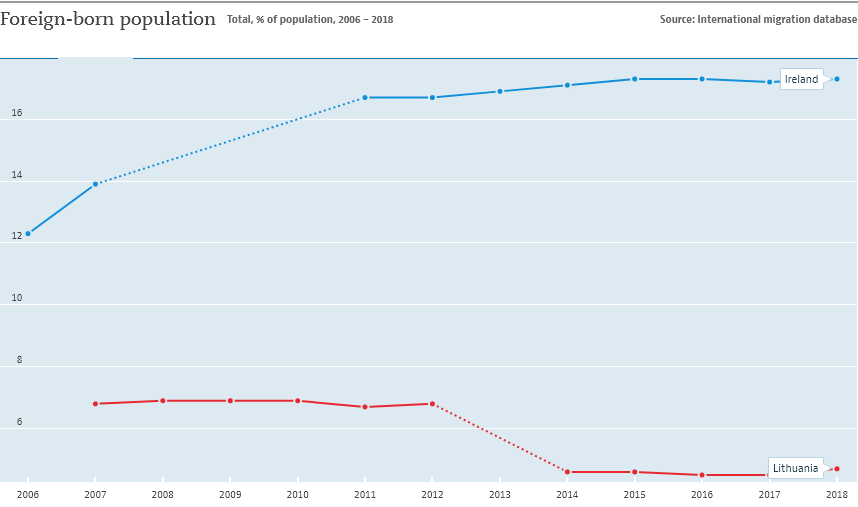Point out several critical features in this image. The given graph compares the population growth rates of Ireland and Lithuania. The foreign-born population in Lithuania exceeded 6% for a period of years. 